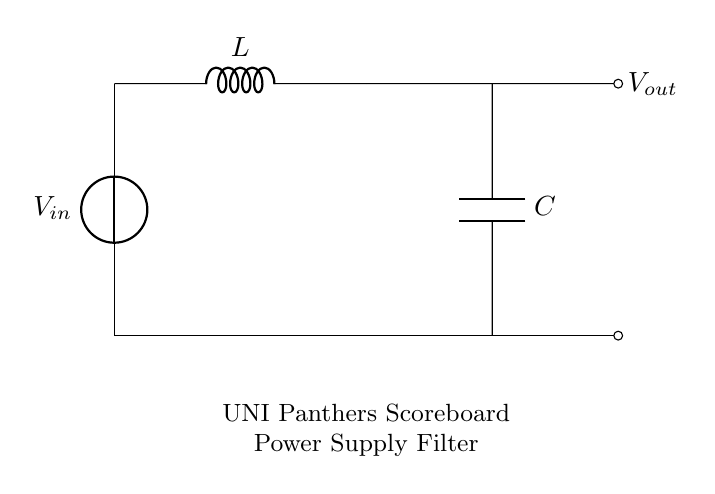What is the input voltage of the circuit? The input voltage is provided by the voltage source labeled V_in at the top of the circuit. It is the starting point for the power supply.
Answer: V_in What type of filter is used in this circuit? The circuit includes an inductor and a capacitor arranged in series, which characterizes it as a passive LC filter. The inductor and capacitor work together to smooth out power supply fluctuations.
Answer: LC filter What are the components used in the circuit? The components are identified in the diagram as a voltage source, an inductor (L), and a capacitor (C). These are the essential elements constituting the filter.
Answer: Voltage source, inductor, capacitor How does the output voltage relate to the input voltage? The output voltage, denoted as V_out, is taken across the capacitor and reflects the smoothened voltage after filtering. It is generally lower than the input voltage due to the voltage drop across the inductor and the reactive nature of the components.
Answer: V_out What is the function of the inductor in this circuit? The inductor in this circuit opposes changes in current and helps to smooth out fluctuations in the input voltage by storing energy in its magnetic field, which aids in transient response and reduces ripples in the output voltage.
Answer: Smooth fluctuations What is the primary purpose of this circuit? The circuit's primary purpose is to filter out fluctuations in the power supply to provide a stable voltage output for the scoreboard system of the UNI Panthers arena. It ensures consistent performance of the electronic scoreboard.
Answer: Smoothing power supply fluctuations 